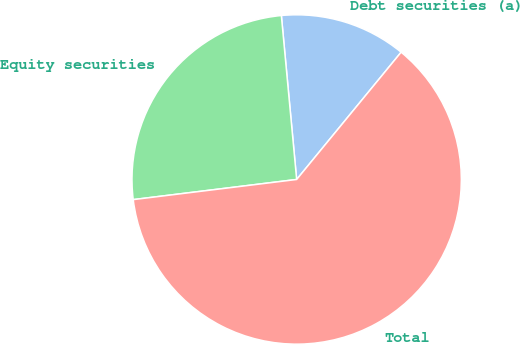Convert chart to OTSL. <chart><loc_0><loc_0><loc_500><loc_500><pie_chart><fcel>Debt securities (a)<fcel>Equity securities<fcel>Total<nl><fcel>12.42%<fcel>25.47%<fcel>62.11%<nl></chart> 